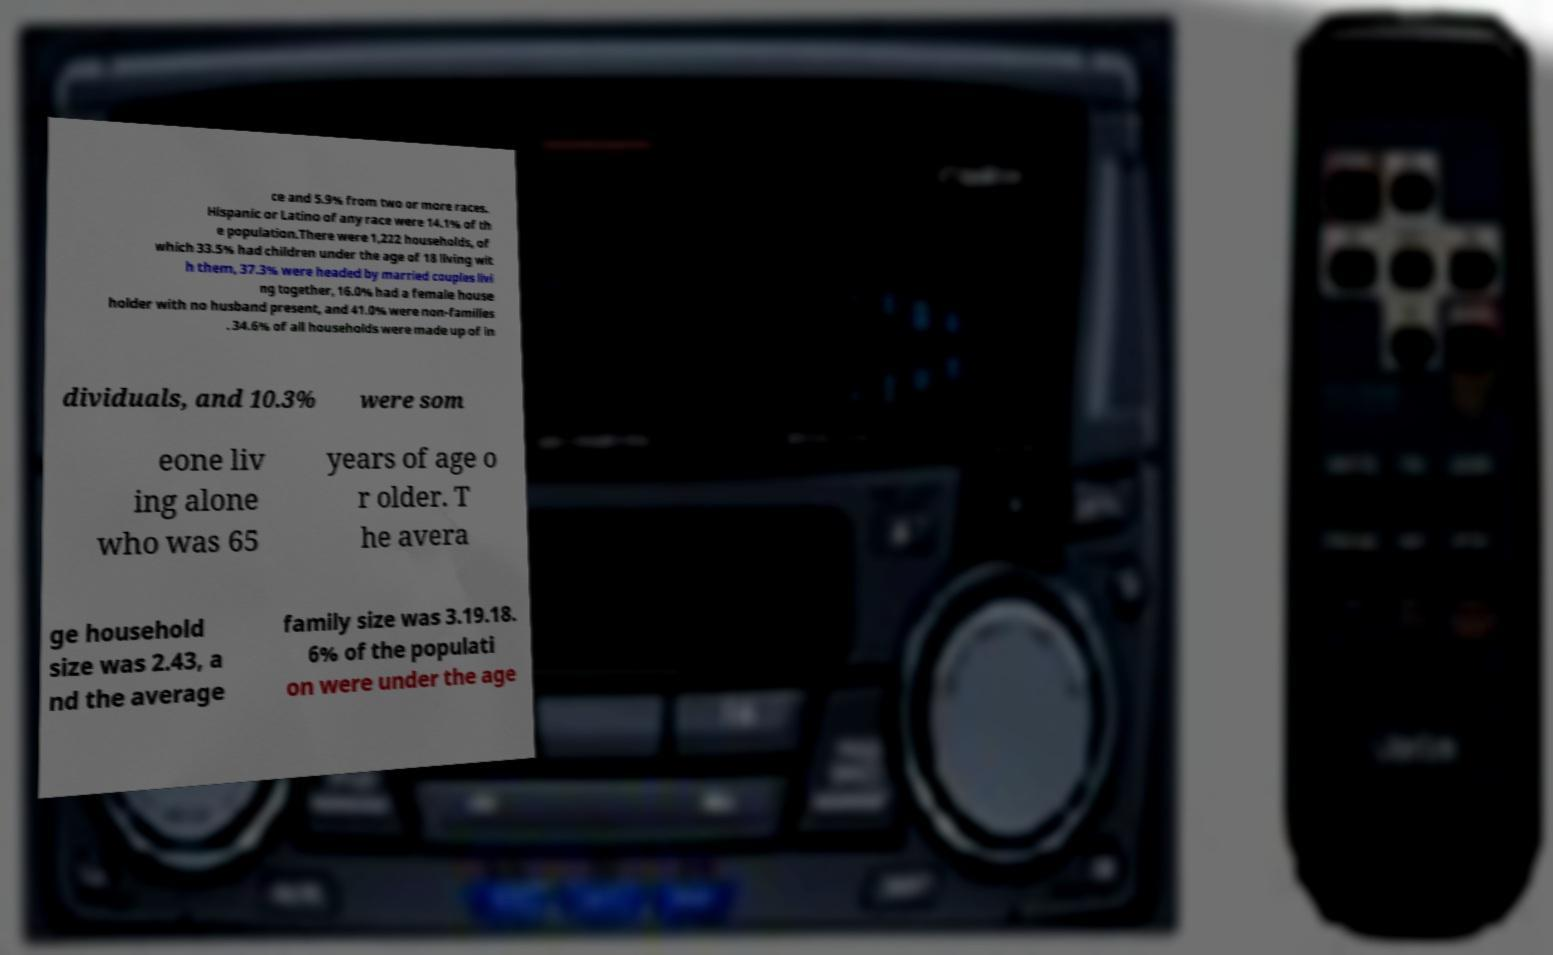Please identify and transcribe the text found in this image. ce and 5.9% from two or more races. Hispanic or Latino of any race were 14.1% of th e population.There were 1,222 households, of which 33.5% had children under the age of 18 living wit h them, 37.3% were headed by married couples livi ng together, 16.0% had a female house holder with no husband present, and 41.0% were non-families . 34.6% of all households were made up of in dividuals, and 10.3% were som eone liv ing alone who was 65 years of age o r older. T he avera ge household size was 2.43, a nd the average family size was 3.19.18. 6% of the populati on were under the age 